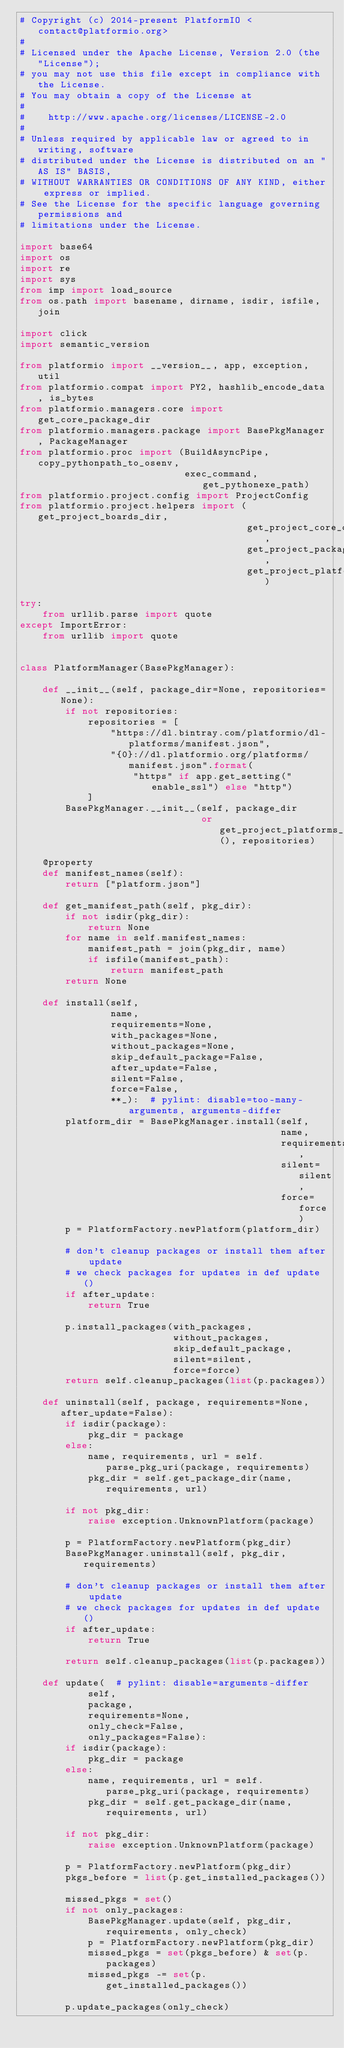Convert code to text. <code><loc_0><loc_0><loc_500><loc_500><_Python_># Copyright (c) 2014-present PlatformIO <contact@platformio.org>
#
# Licensed under the Apache License, Version 2.0 (the "License");
# you may not use this file except in compliance with the License.
# You may obtain a copy of the License at
#
#    http://www.apache.org/licenses/LICENSE-2.0
#
# Unless required by applicable law or agreed to in writing, software
# distributed under the License is distributed on an "AS IS" BASIS,
# WITHOUT WARRANTIES OR CONDITIONS OF ANY KIND, either express or implied.
# See the License for the specific language governing permissions and
# limitations under the License.

import base64
import os
import re
import sys
from imp import load_source
from os.path import basename, dirname, isdir, isfile, join

import click
import semantic_version

from platformio import __version__, app, exception, util
from platformio.compat import PY2, hashlib_encode_data, is_bytes
from platformio.managers.core import get_core_package_dir
from platformio.managers.package import BasePkgManager, PackageManager
from platformio.proc import (BuildAsyncPipe, copy_pythonpath_to_osenv,
                             exec_command, get_pythonexe_path)
from platformio.project.config import ProjectConfig
from platformio.project.helpers import (get_project_boards_dir,
                                        get_project_core_dir,
                                        get_project_packages_dir,
                                        get_project_platforms_dir)

try:
    from urllib.parse import quote
except ImportError:
    from urllib import quote


class PlatformManager(BasePkgManager):

    def __init__(self, package_dir=None, repositories=None):
        if not repositories:
            repositories = [
                "https://dl.bintray.com/platformio/dl-platforms/manifest.json",
                "{0}://dl.platformio.org/platforms/manifest.json".format(
                    "https" if app.get_setting("enable_ssl") else "http")
            ]
        BasePkgManager.__init__(self, package_dir
                                or get_project_platforms_dir(), repositories)

    @property
    def manifest_names(self):
        return ["platform.json"]

    def get_manifest_path(self, pkg_dir):
        if not isdir(pkg_dir):
            return None
        for name in self.manifest_names:
            manifest_path = join(pkg_dir, name)
            if isfile(manifest_path):
                return manifest_path
        return None

    def install(self,
                name,
                requirements=None,
                with_packages=None,
                without_packages=None,
                skip_default_package=False,
                after_update=False,
                silent=False,
                force=False,
                **_):  # pylint: disable=too-many-arguments, arguments-differ
        platform_dir = BasePkgManager.install(self,
                                              name,
                                              requirements,
                                              silent=silent,
                                              force=force)
        p = PlatformFactory.newPlatform(platform_dir)

        # don't cleanup packages or install them after update
        # we check packages for updates in def update()
        if after_update:
            return True

        p.install_packages(with_packages,
                           without_packages,
                           skip_default_package,
                           silent=silent,
                           force=force)
        return self.cleanup_packages(list(p.packages))

    def uninstall(self, package, requirements=None, after_update=False):
        if isdir(package):
            pkg_dir = package
        else:
            name, requirements, url = self.parse_pkg_uri(package, requirements)
            pkg_dir = self.get_package_dir(name, requirements, url)

        if not pkg_dir:
            raise exception.UnknownPlatform(package)

        p = PlatformFactory.newPlatform(pkg_dir)
        BasePkgManager.uninstall(self, pkg_dir, requirements)

        # don't cleanup packages or install them after update
        # we check packages for updates in def update()
        if after_update:
            return True

        return self.cleanup_packages(list(p.packages))

    def update(  # pylint: disable=arguments-differ
            self,
            package,
            requirements=None,
            only_check=False,
            only_packages=False):
        if isdir(package):
            pkg_dir = package
        else:
            name, requirements, url = self.parse_pkg_uri(package, requirements)
            pkg_dir = self.get_package_dir(name, requirements, url)

        if not pkg_dir:
            raise exception.UnknownPlatform(package)

        p = PlatformFactory.newPlatform(pkg_dir)
        pkgs_before = list(p.get_installed_packages())

        missed_pkgs = set()
        if not only_packages:
            BasePkgManager.update(self, pkg_dir, requirements, only_check)
            p = PlatformFactory.newPlatform(pkg_dir)
            missed_pkgs = set(pkgs_before) & set(p.packages)
            missed_pkgs -= set(p.get_installed_packages())

        p.update_packages(only_check)</code> 